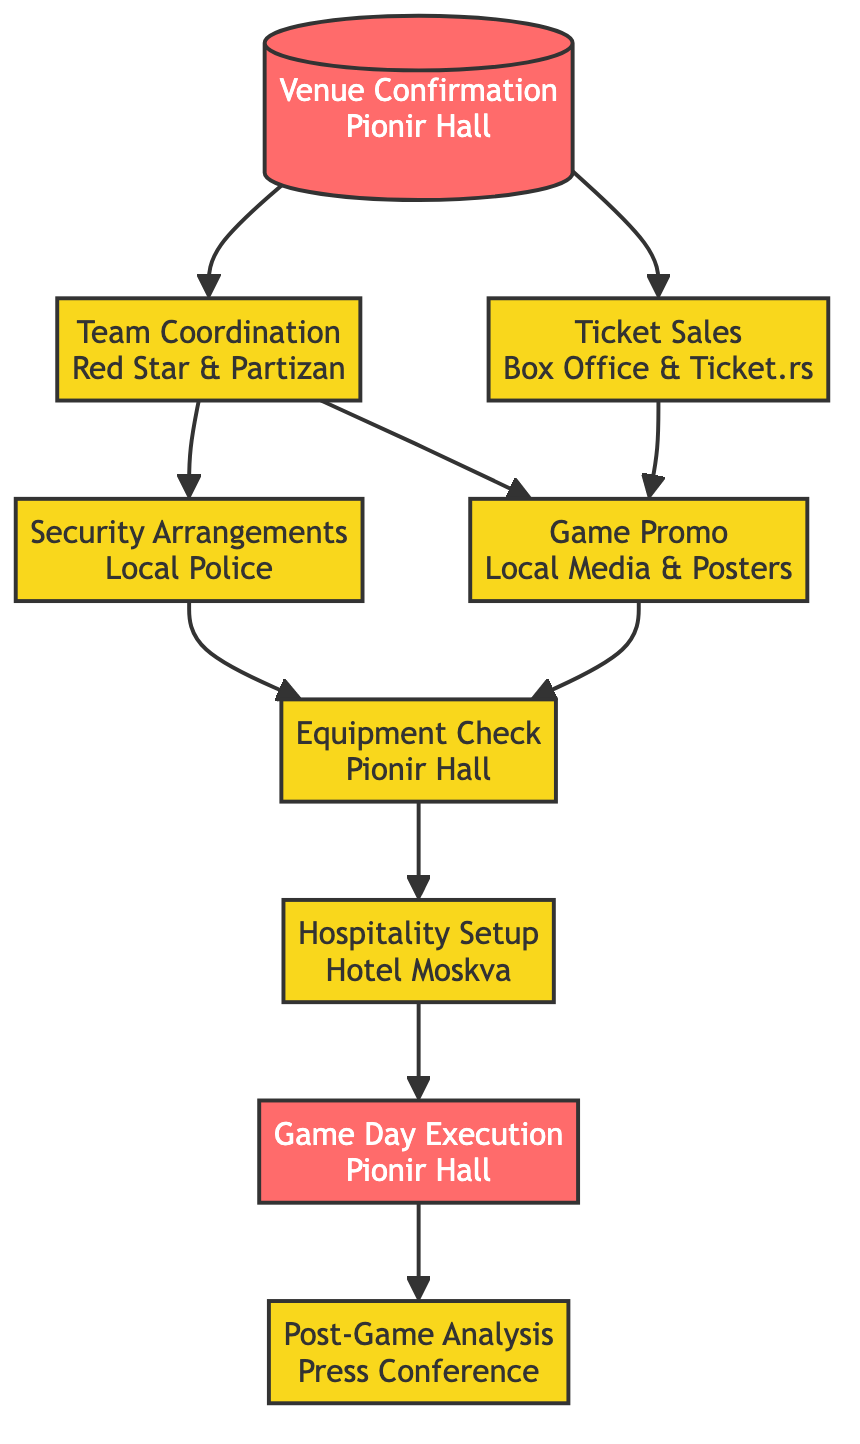What is the first step in hosting a YUBA League game? The first step is "Venue Confirmation," where it ensures that Pionir Hall is available and reserved for the game date.
Answer: Venue Confirmation How many main stages are there in the process? By counting the nodes (steps) in the diagram, there are nine main stages to the process of hosting the game.
Answer: Nine Which teams need to be coordinated with? The diagram indicates that the two teams to coordinate with are Red Star and Partizan.
Answer: Red Star and Partizan What do security arrangements involve? Security arrangements involve coordinating with local police and security services to ensure safety measures are in place, as depicted in the diagram.
Answer: Local Police In what way does "Ticket Sales" relate to "Game Promo"? "Ticket Sales" and "Game Promo" are connected since "Ticket Sales" opens opportunity for game attendance, which should be advertised through "Game Promo" as a means to encourage purchases.
Answer: They are connected Which step comes after "Hospitality Setup"? Following "Hospitality Setup," the next step in the flow is "Game Day Execution," indicating preparations for the actual game day activities.
Answer: Game Day Execution What happens on "Game Day Execution"? "Game Day Execution" includes ensuring smooth entry for fans, managing the game clock, and overseeing halftime entertainment during the game day.
Answer: Entry for fans, game clock management, halftime entertainment What stage must be completed before "Post-Game Analysis"? "Game Day Execution" must be completed before moving on to "Post-Game Analysis," as it logically flows from the event to the analysis discussions afterward.
Answer: Game Day Execution Which step involves checking basketball equipment? The step "Equipment Check" involves verifying that all basketball equipment and facilities in Pionir Hall are functioning properly.
Answer: Equipment Check 